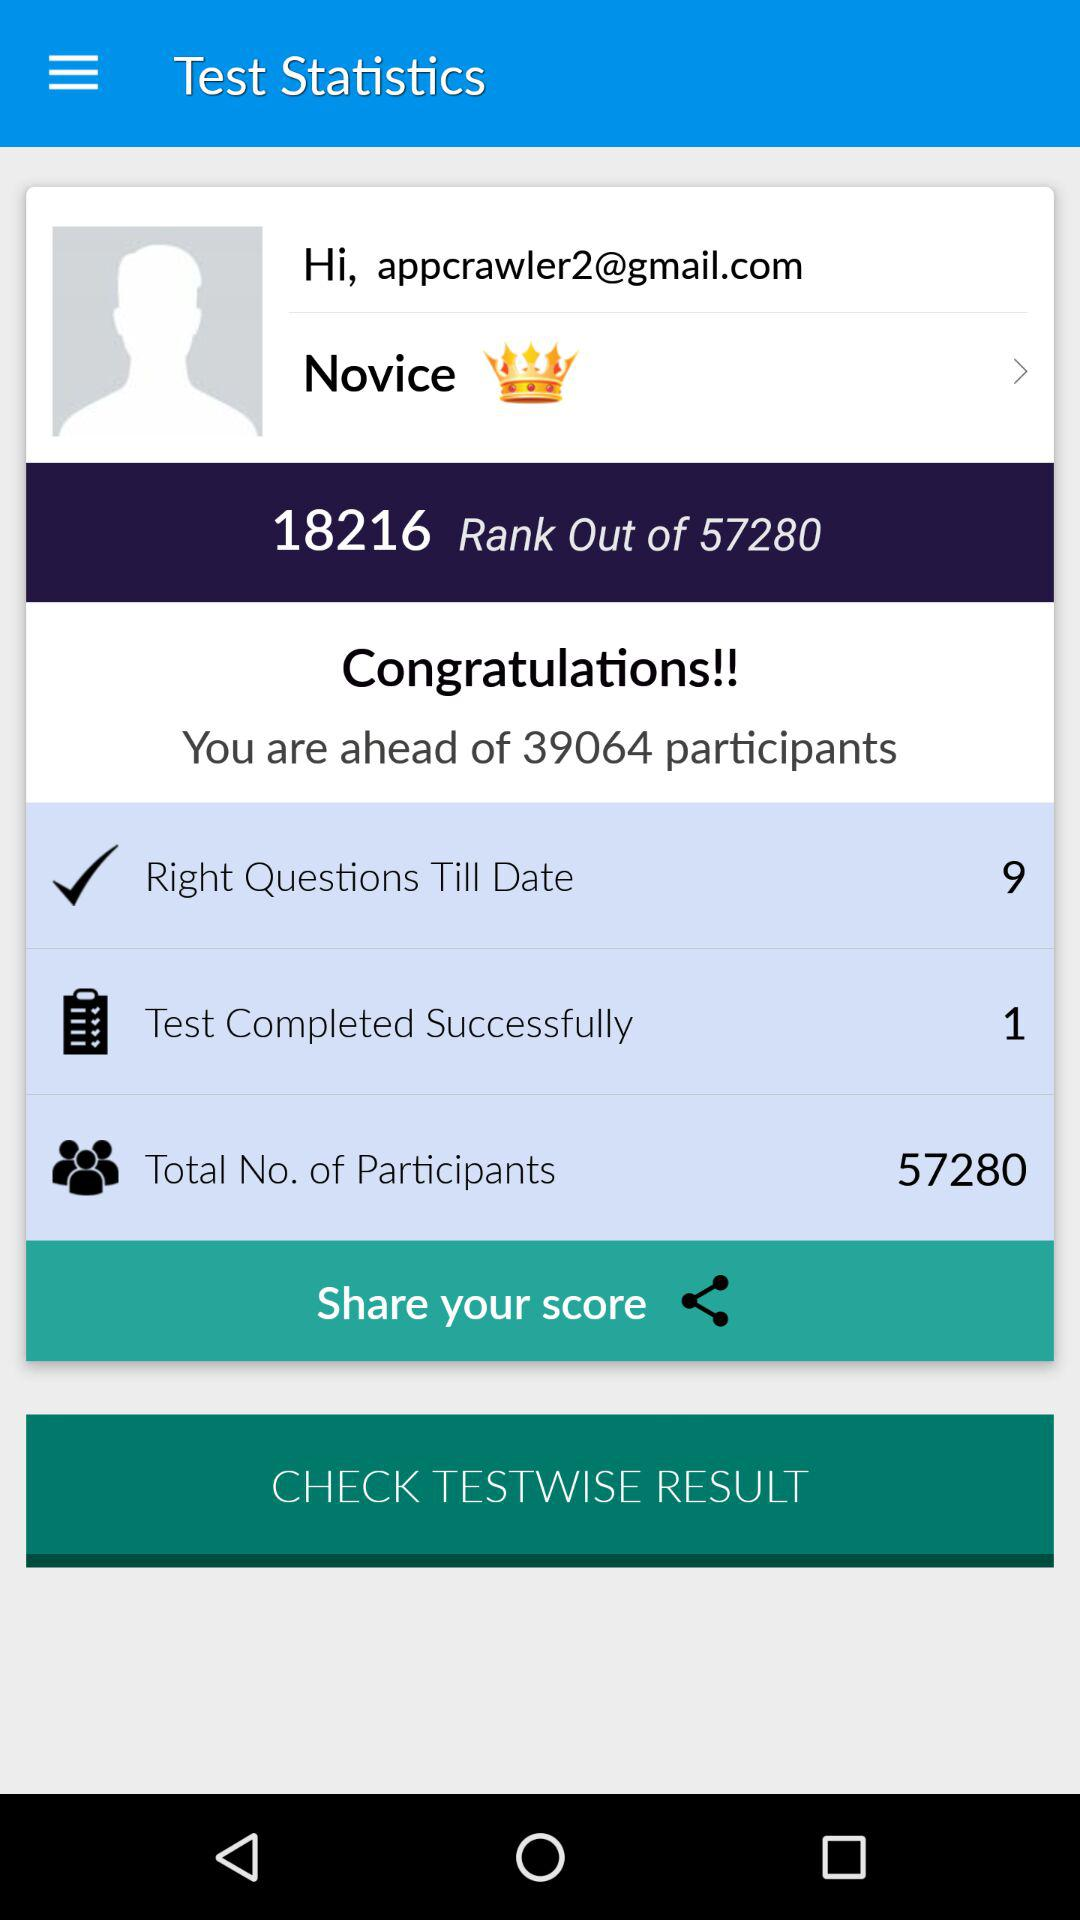What is the total rank given on the screen? The total rank given on the screen is 57280. 